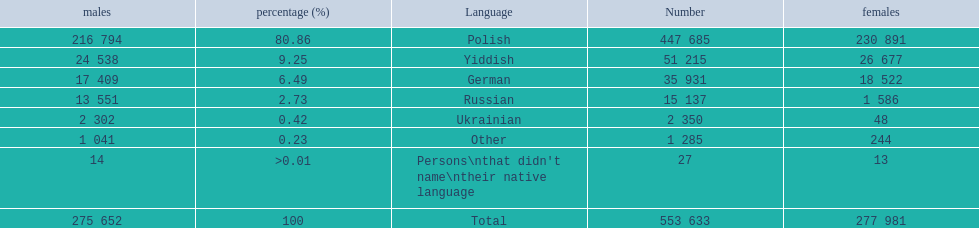What are the percentages of people? 80.86, 9.25, 6.49, 2.73, 0.42, 0.23, >0.01. Which language is .42%? Ukrainian. 